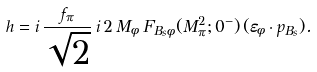Convert formula to latex. <formula><loc_0><loc_0><loc_500><loc_500>h = i \, \frac { f _ { \pi } } { \sqrt { 2 } } \, i \, 2 \, M _ { \phi } \, F _ { B _ { s } \phi } ( M _ { \pi } ^ { 2 } ; 0 ^ { - } ) \, ( \varepsilon _ { \phi } \cdot p _ { B _ { s } } ) .</formula> 